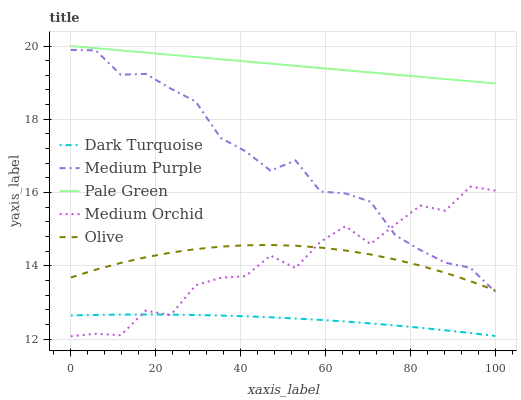Does Dark Turquoise have the minimum area under the curve?
Answer yes or no. Yes. Does Pale Green have the maximum area under the curve?
Answer yes or no. Yes. Does Medium Orchid have the minimum area under the curve?
Answer yes or no. No. Does Medium Orchid have the maximum area under the curve?
Answer yes or no. No. Is Pale Green the smoothest?
Answer yes or no. Yes. Is Medium Orchid the roughest?
Answer yes or no. Yes. Is Dark Turquoise the smoothest?
Answer yes or no. No. Is Dark Turquoise the roughest?
Answer yes or no. No. Does Medium Orchid have the lowest value?
Answer yes or no. Yes. Does Dark Turquoise have the lowest value?
Answer yes or no. No. Does Pale Green have the highest value?
Answer yes or no. Yes. Does Medium Orchid have the highest value?
Answer yes or no. No. Is Medium Orchid less than Pale Green?
Answer yes or no. Yes. Is Olive greater than Dark Turquoise?
Answer yes or no. Yes. Does Dark Turquoise intersect Medium Orchid?
Answer yes or no. Yes. Is Dark Turquoise less than Medium Orchid?
Answer yes or no. No. Is Dark Turquoise greater than Medium Orchid?
Answer yes or no. No. Does Medium Orchid intersect Pale Green?
Answer yes or no. No. 